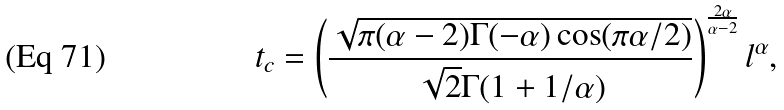Convert formula to latex. <formula><loc_0><loc_0><loc_500><loc_500>t _ { c } = \left ( \frac { \sqrt { \pi ( \alpha - 2 ) \Gamma ( - \alpha ) \cos ( \pi \alpha / 2 ) } } { \sqrt { 2 } \Gamma ( 1 + 1 / \alpha ) } \right ) ^ { \frac { 2 \alpha } { \alpha - 2 } } l ^ { \alpha } ,</formula> 